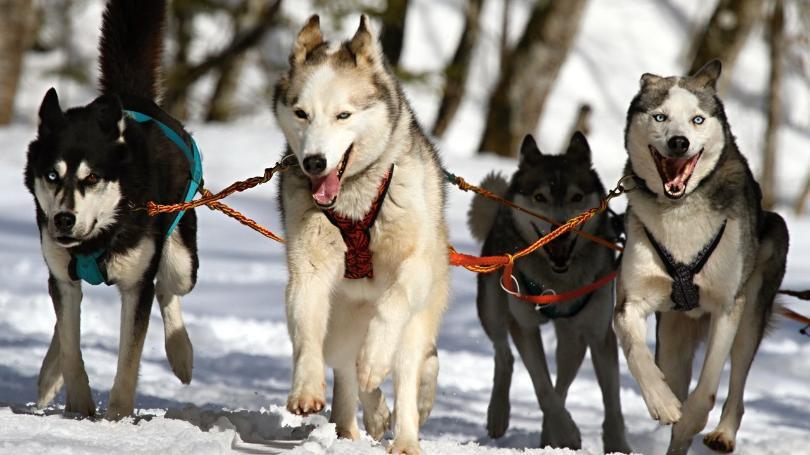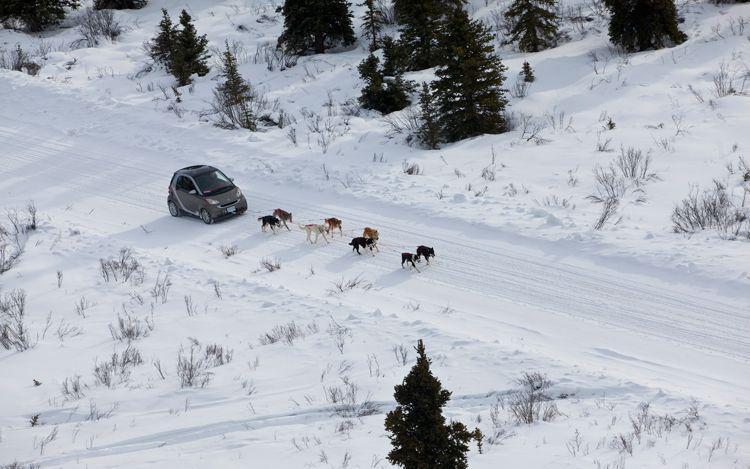The first image is the image on the left, the second image is the image on the right. For the images shown, is this caption "In the left image there are sled dogs up close pulling straight ahead towards the camera." true? Answer yes or no. Yes. 